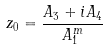<formula> <loc_0><loc_0><loc_500><loc_500>z _ { 0 } = \frac { A _ { 3 } + i A _ { 4 } } { A ^ { m } _ { 1 } }</formula> 